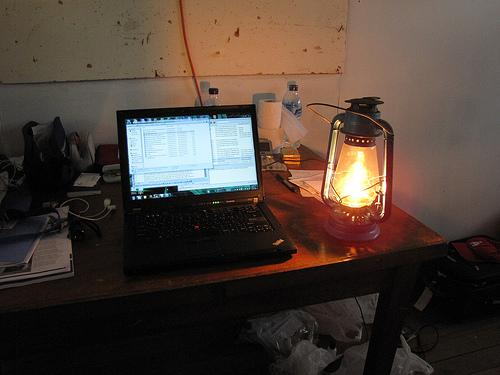Question: where is the lantern?
Choices:
A. On the ground.
B. On the table.
C. On the fence.
D. On the counter.
Answer with the letter. Answer: B Question: what color is the wall?
Choices:
A. Green.
B. Blue.
C. White.
D. Black.
Answer with the letter. Answer: C 